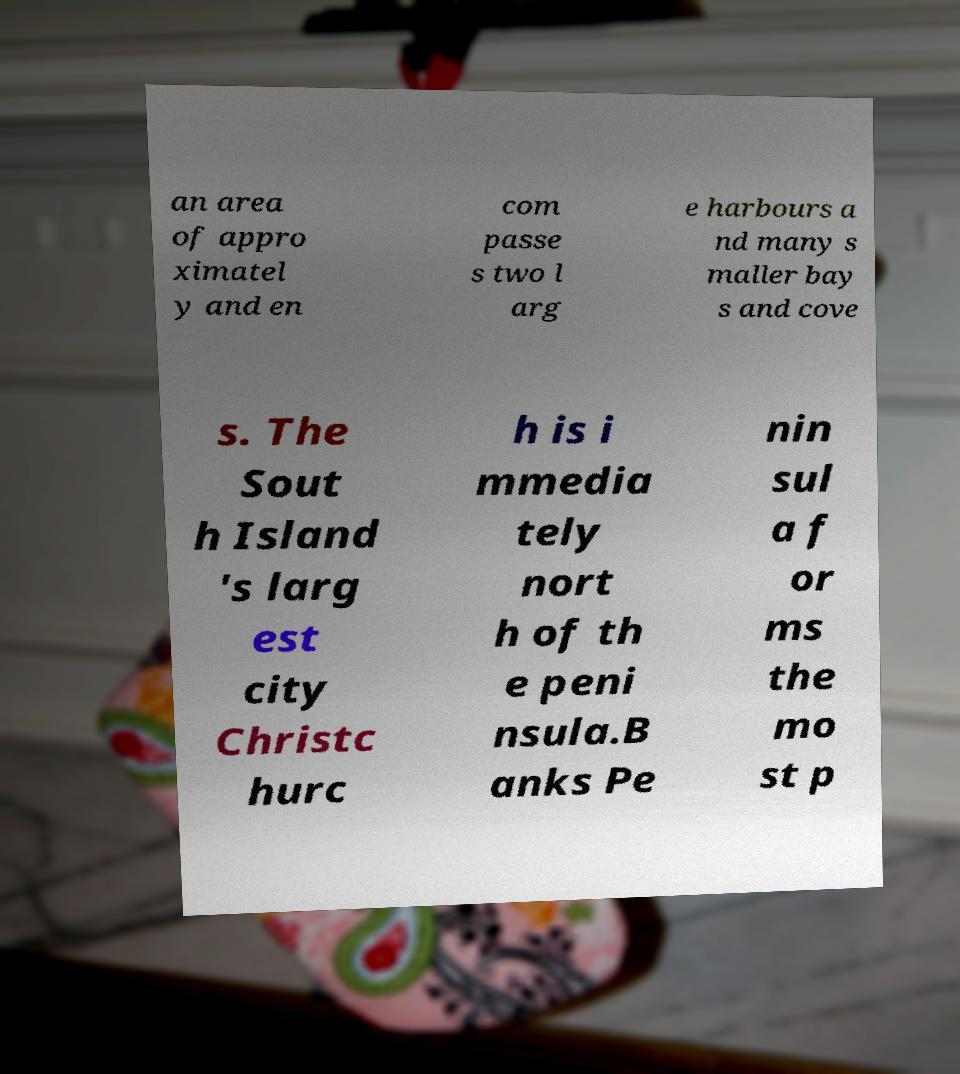For documentation purposes, I need the text within this image transcribed. Could you provide that? an area of appro ximatel y and en com passe s two l arg e harbours a nd many s maller bay s and cove s. The Sout h Island 's larg est city Christc hurc h is i mmedia tely nort h of th e peni nsula.B anks Pe nin sul a f or ms the mo st p 